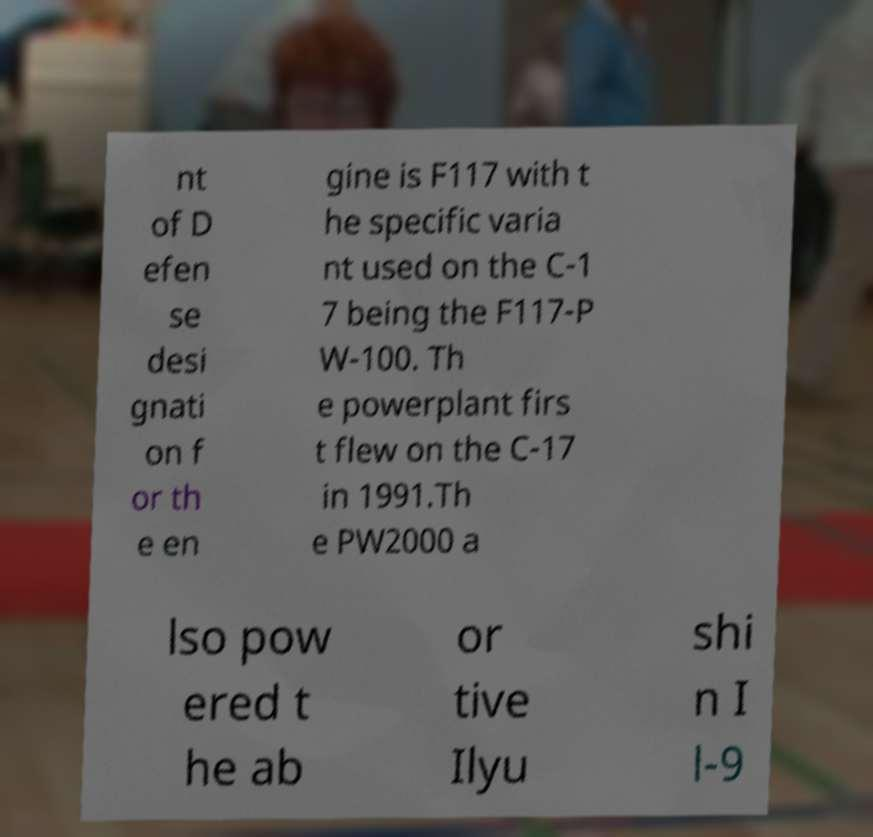Please read and relay the text visible in this image. What does it say? nt of D efen se desi gnati on f or th e en gine is F117 with t he specific varia nt used on the C-1 7 being the F117-P W-100. Th e powerplant firs t flew on the C-17 in 1991.Th e PW2000 a lso pow ered t he ab or tive Ilyu shi n I l-9 